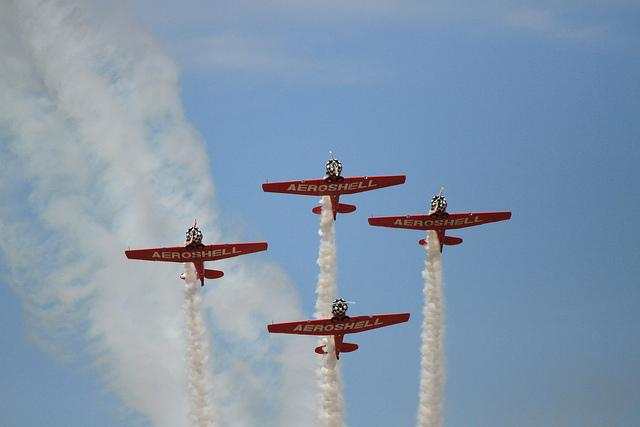What are these planes emitting? Please explain your reasoning. contrails. The planes have contrails. 